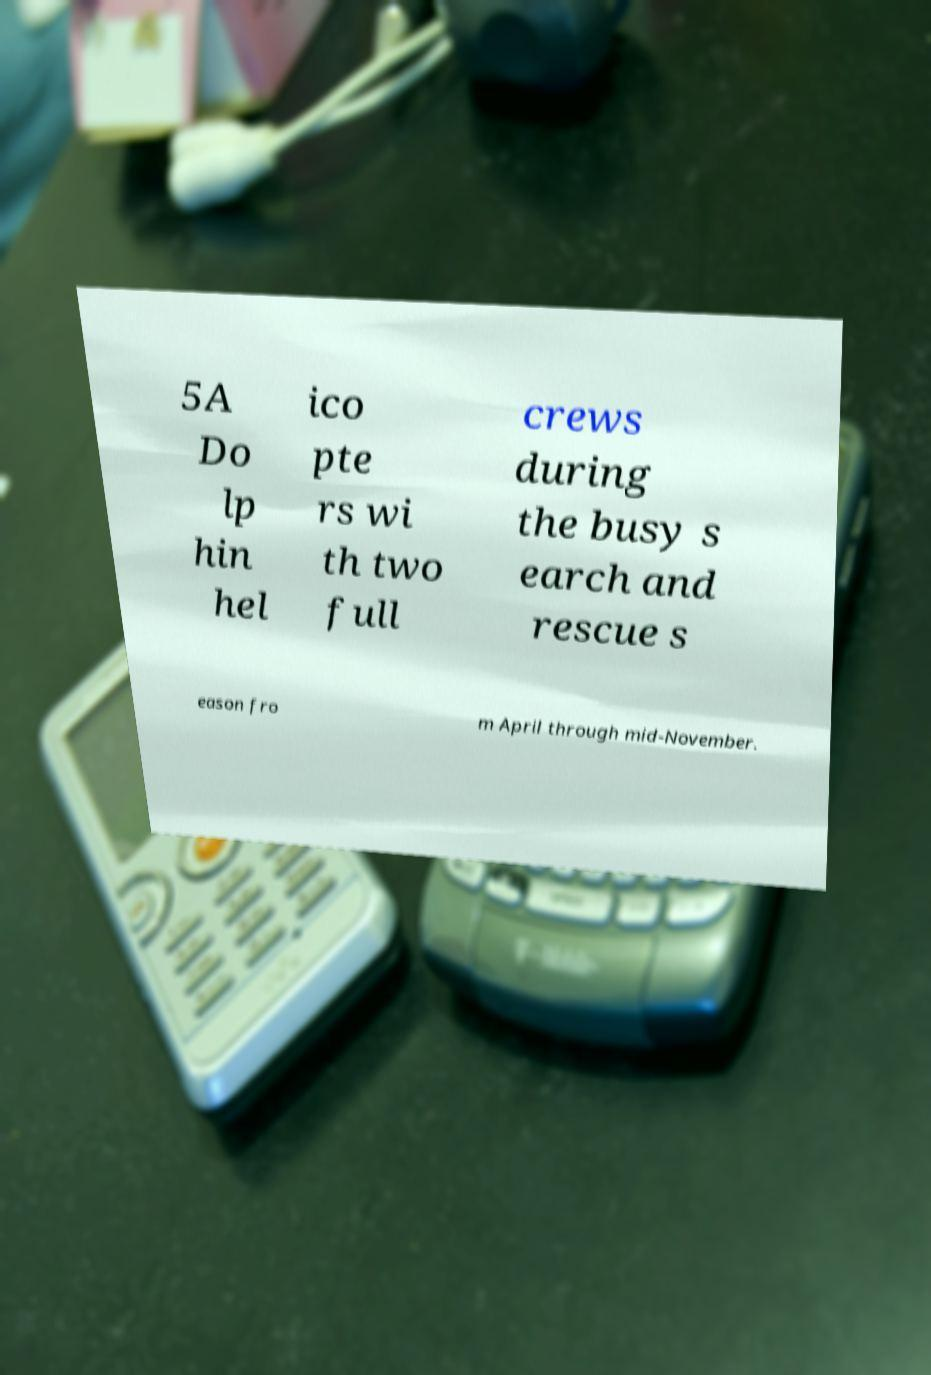For documentation purposes, I need the text within this image transcribed. Could you provide that? 5A Do lp hin hel ico pte rs wi th two full crews during the busy s earch and rescue s eason fro m April through mid-November. 